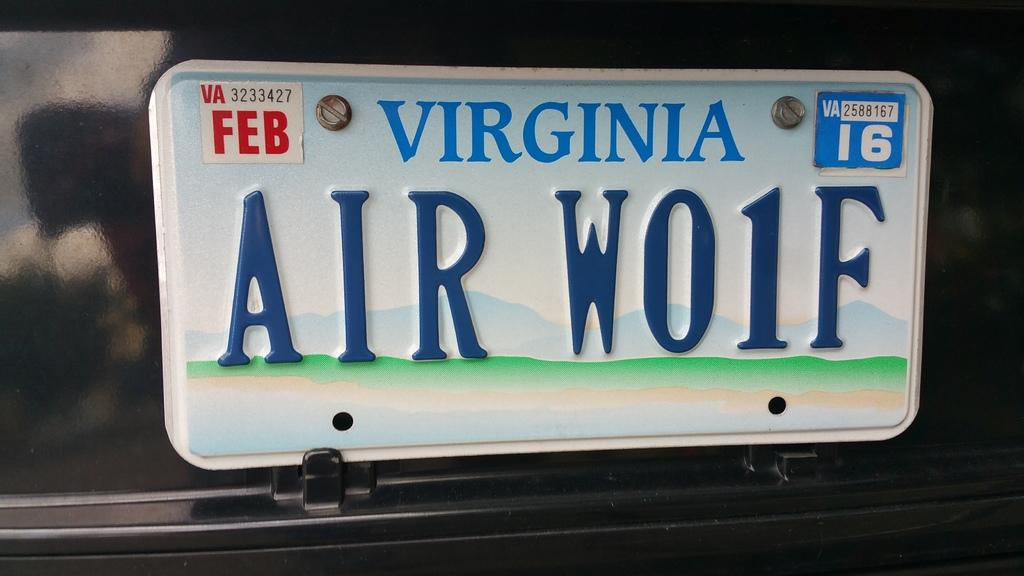<image>
Summarize the visual content of the image. A Virginia tag that reads AIR W01F on a black car. 